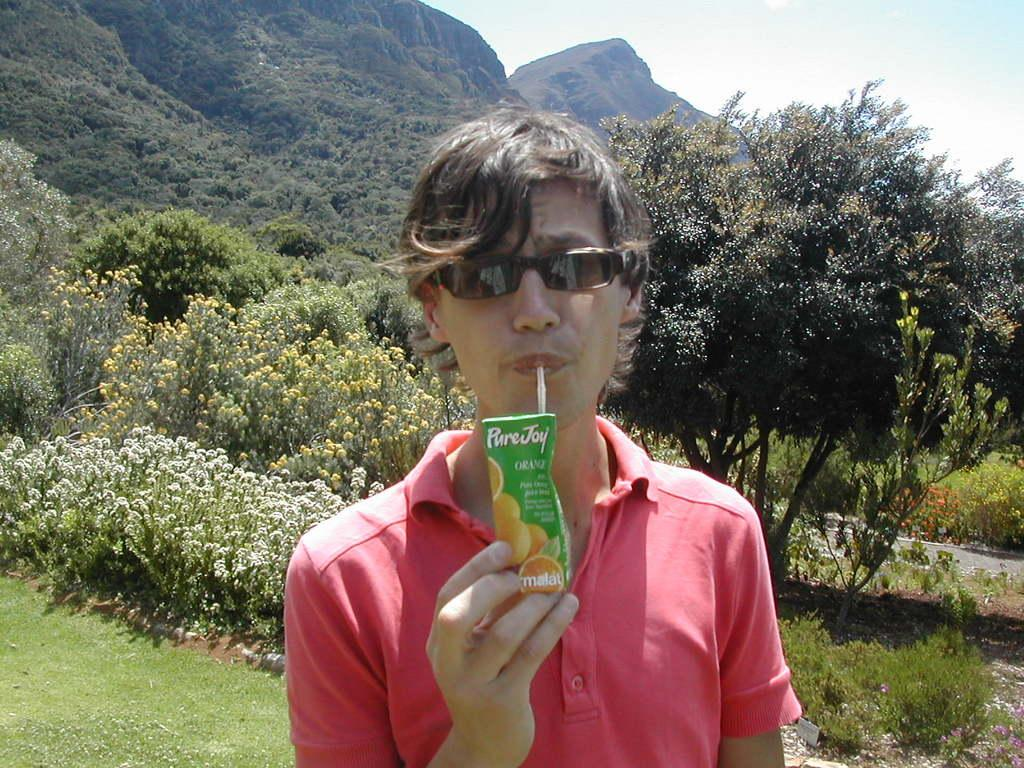What is the person in the image doing? The person is drinking. What is the ground like in the image? The ground is visible, and there is grass present on it. What type of vegetation can be seen in the image? Plants, flowers, and trees are present in the image. What is the landscape like in the image? Mountains are visible in the image, along with a road and the sky. What type of grain is being harvested in the image? There is no grain present in the image, and no harvesting activity is depicted. How many dogs are visible in the image? There are no dogs present in the image. 